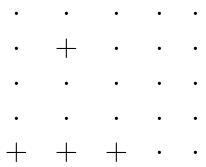<formula> <loc_0><loc_0><loc_500><loc_500>\begin{matrix} \, \cdot \, & \, \cdot \, & \, \cdot \, & \, \cdot \, & \, \cdot \, \\ \, \cdot \, & \, + \, & \, \cdot \, & \, \cdot \, & \, \cdot \, \\ \, \cdot \, & \, \cdot \, & \, \cdot \, & \, \cdot \, & \, \cdot \, \\ \, \cdot \, & \, \cdot \, & \, \cdot \, & \, \cdot \, & \, \cdot \, \\ \, + \, & \, + \, & \, + \, & \, \cdot \, & \, \cdot \, \\ \end{matrix}</formula> 